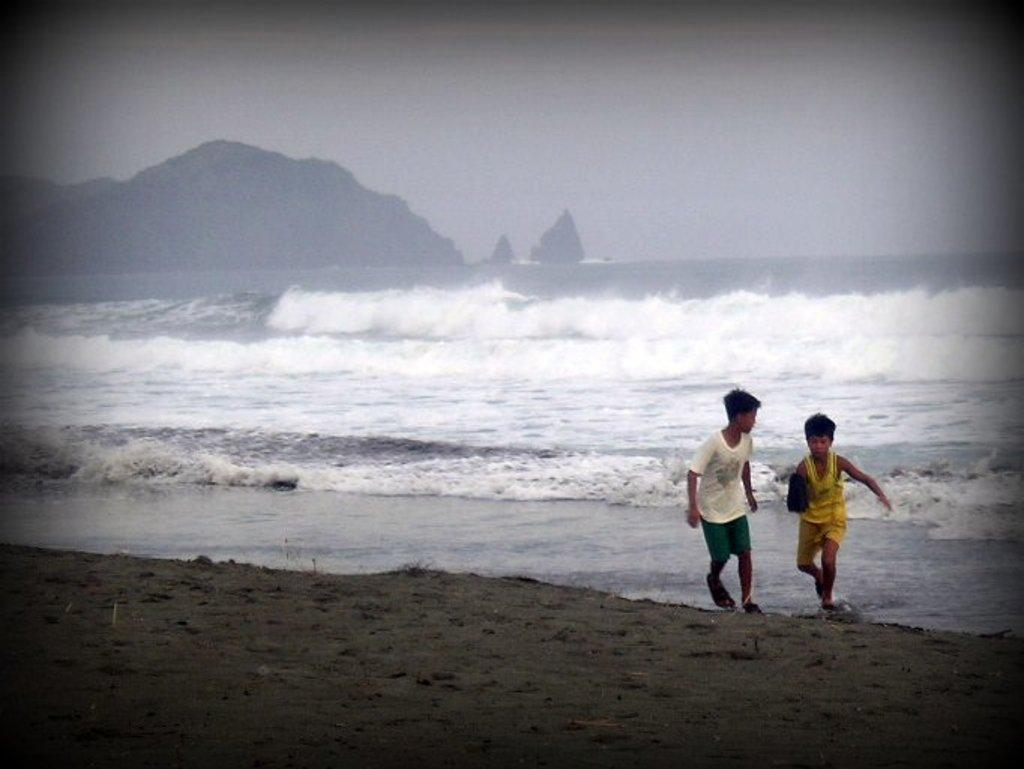How many people are in the image? There are two boys in the image. What are the boys doing in the image? The boys are running on sand. What can be seen in the background of the image? There is water, mountains, and the sky visible in the background of the image. What type of balance exercise are the boys performing in the image? The boys are running, not performing a balance exercise, in the image. What is the destination of the boys' voyage in the image? There is no indication of a voyage in the image; the boys are simply running on sand. 